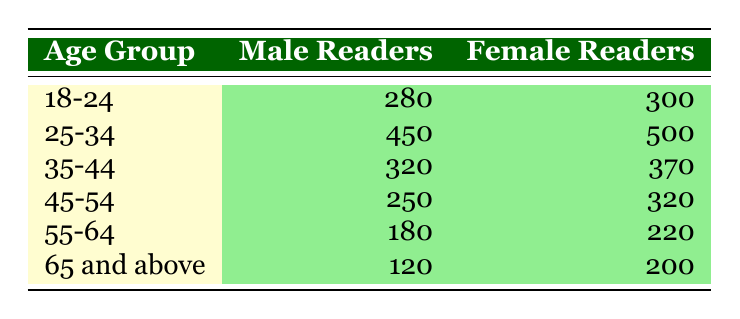How many male readers are there in the age group 25-34? According to the table, the number of male readers in the age group 25-34 is directly provided as 450.
Answer: 450 What is the total number of female readers across all age groups? To find the total number of female readers, sum the values from the female readers column: 300 + 500 + 370 + 320 + 220 + 200 = 1910.
Answer: 1910 Are there more female readers than male readers in the age group 45-54? In the age group 45-54, there are 320 female readers and 250 male readers. Since 320 is greater than 250, the answer is yes.
Answer: Yes What is the age group with the highest number of male readers? By reviewing the male readers column, the age group 25-34 has the highest number at 450, which is greater than all other age groups.
Answer: 25-34 What is the average number of readers (male and female) for the age group 35-44? For the age group 35-44, there are 320 male readers and 370 female readers. The total for this age group is 320 + 370 = 690. The average is thus 690/2 = 345.
Answer: 345 How many more female readers are there in the age group 18-24 compared to the age group 65 and above? In the age group 18-24, there are 300 female readers, while in the age group 65 and above, there are 200 female readers. The difference is 300 - 200 = 100.
Answer: 100 Is the number of male readers in the age group 55-64 less than that in the age group 65 and above? The male readers in the age group 55-64 are 180, while in the age group 65 and above they are 120. Since 180 is greater than 120, the statement is false.
Answer: No What is the total number of readers in the age group 55-64? To find the total in the age group 55-64, add the number of male readers (180) to female readers (220) which gives 180 + 220 = 400.
Answer: 400 Which age group has the smallest number of female readers? Reviewing the female readers column, the age group 65 and above has 200 female readers, which is lesser than all other age groups' female counts.
Answer: 65 and above 